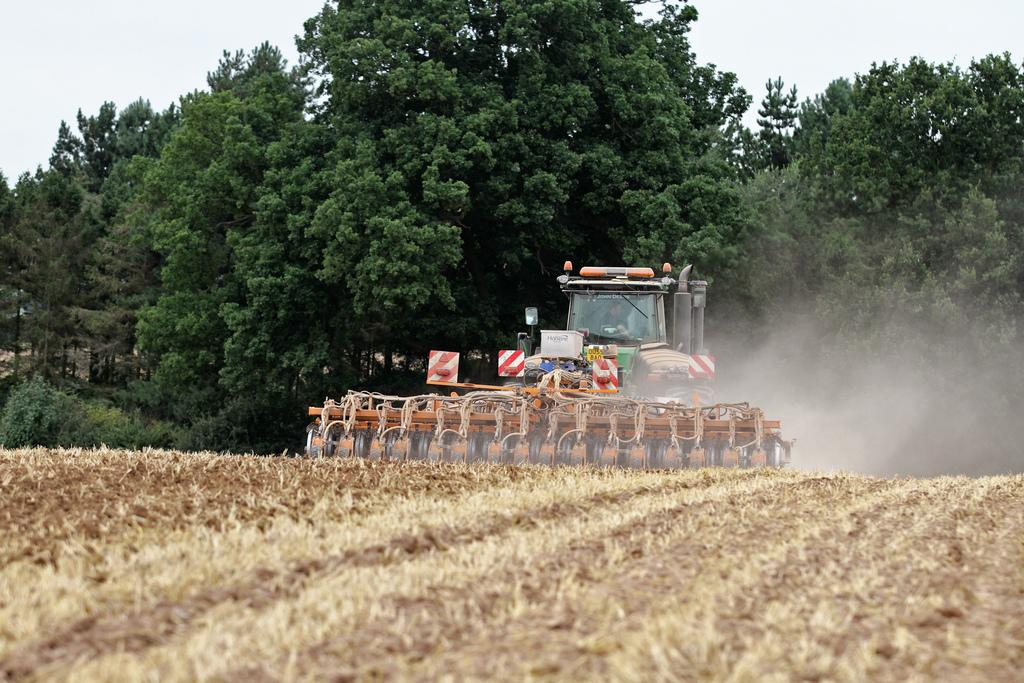What is the main object in the field in the image? There is a harvesting machine in the field. Is there anyone operating the harvesting machine? Yes, a person is seated in the harvesting machine. What can be seen in the background of the image? There are trees in the background of the image. How many hands does the farmer have in the image? There is no farmer present in the image, and therefore no hands can be counted. 